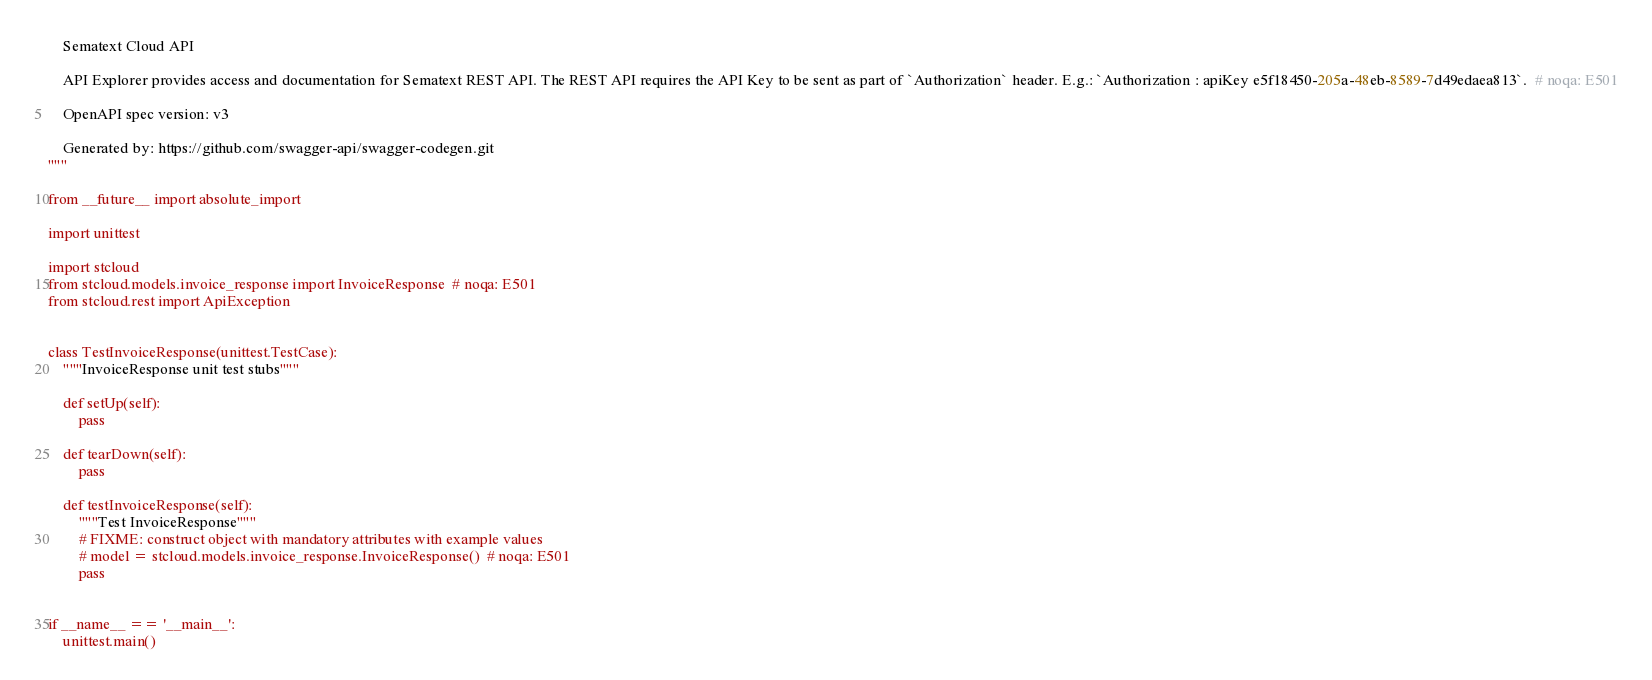Convert code to text. <code><loc_0><loc_0><loc_500><loc_500><_Python_>    Sematext Cloud API

    API Explorer provides access and documentation for Sematext REST API. The REST API requires the API Key to be sent as part of `Authorization` header. E.g.: `Authorization : apiKey e5f18450-205a-48eb-8589-7d49edaea813`.  # noqa: E501

    OpenAPI spec version: v3
    
    Generated by: https://github.com/swagger-api/swagger-codegen.git
"""

from __future__ import absolute_import

import unittest

import stcloud
from stcloud.models.invoice_response import InvoiceResponse  # noqa: E501
from stcloud.rest import ApiException


class TestInvoiceResponse(unittest.TestCase):
    """InvoiceResponse unit test stubs"""

    def setUp(self):
        pass

    def tearDown(self):
        pass

    def testInvoiceResponse(self):
        """Test InvoiceResponse"""
        # FIXME: construct object with mandatory attributes with example values
        # model = stcloud.models.invoice_response.InvoiceResponse()  # noqa: E501
        pass


if __name__ == '__main__':
    unittest.main()
</code> 